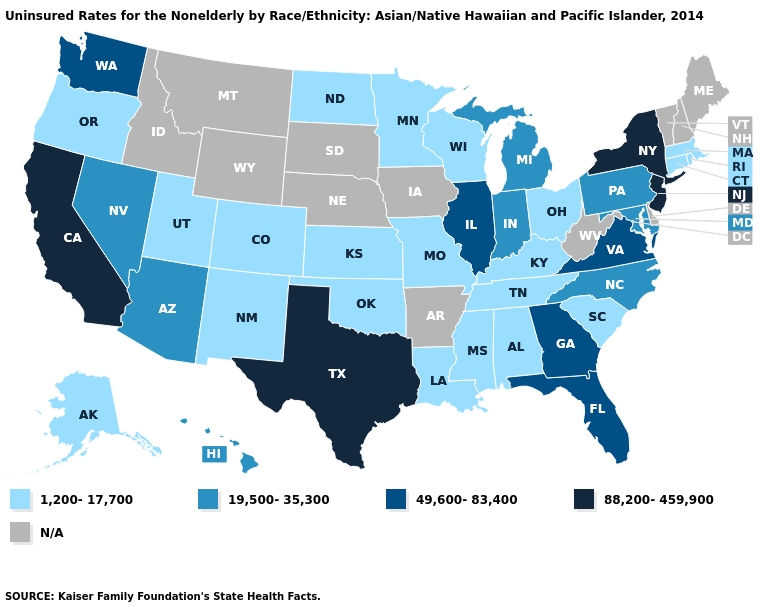Name the states that have a value in the range 49,600-83,400?
Give a very brief answer. Florida, Georgia, Illinois, Virginia, Washington. Does Pennsylvania have the lowest value in the Northeast?
Concise answer only. No. Does Arizona have the lowest value in the West?
Write a very short answer. No. Among the states that border Connecticut , which have the lowest value?
Keep it brief. Massachusetts, Rhode Island. Which states have the lowest value in the Northeast?
Concise answer only. Connecticut, Massachusetts, Rhode Island. What is the lowest value in states that border Pennsylvania?
Answer briefly. 1,200-17,700. What is the value of Rhode Island?
Concise answer only. 1,200-17,700. Among the states that border Kentucky , which have the lowest value?
Short answer required. Missouri, Ohio, Tennessee. Name the states that have a value in the range N/A?
Concise answer only. Arkansas, Delaware, Idaho, Iowa, Maine, Montana, Nebraska, New Hampshire, South Dakota, Vermont, West Virginia, Wyoming. Among the states that border Colorado , does Arizona have the highest value?
Be succinct. Yes. Name the states that have a value in the range 19,500-35,300?
Concise answer only. Arizona, Hawaii, Indiana, Maryland, Michigan, Nevada, North Carolina, Pennsylvania. What is the lowest value in the USA?
Short answer required. 1,200-17,700. Name the states that have a value in the range 19,500-35,300?
Be succinct. Arizona, Hawaii, Indiana, Maryland, Michigan, Nevada, North Carolina, Pennsylvania. What is the value of Illinois?
Keep it brief. 49,600-83,400. Among the states that border Wyoming , which have the lowest value?
Keep it brief. Colorado, Utah. 